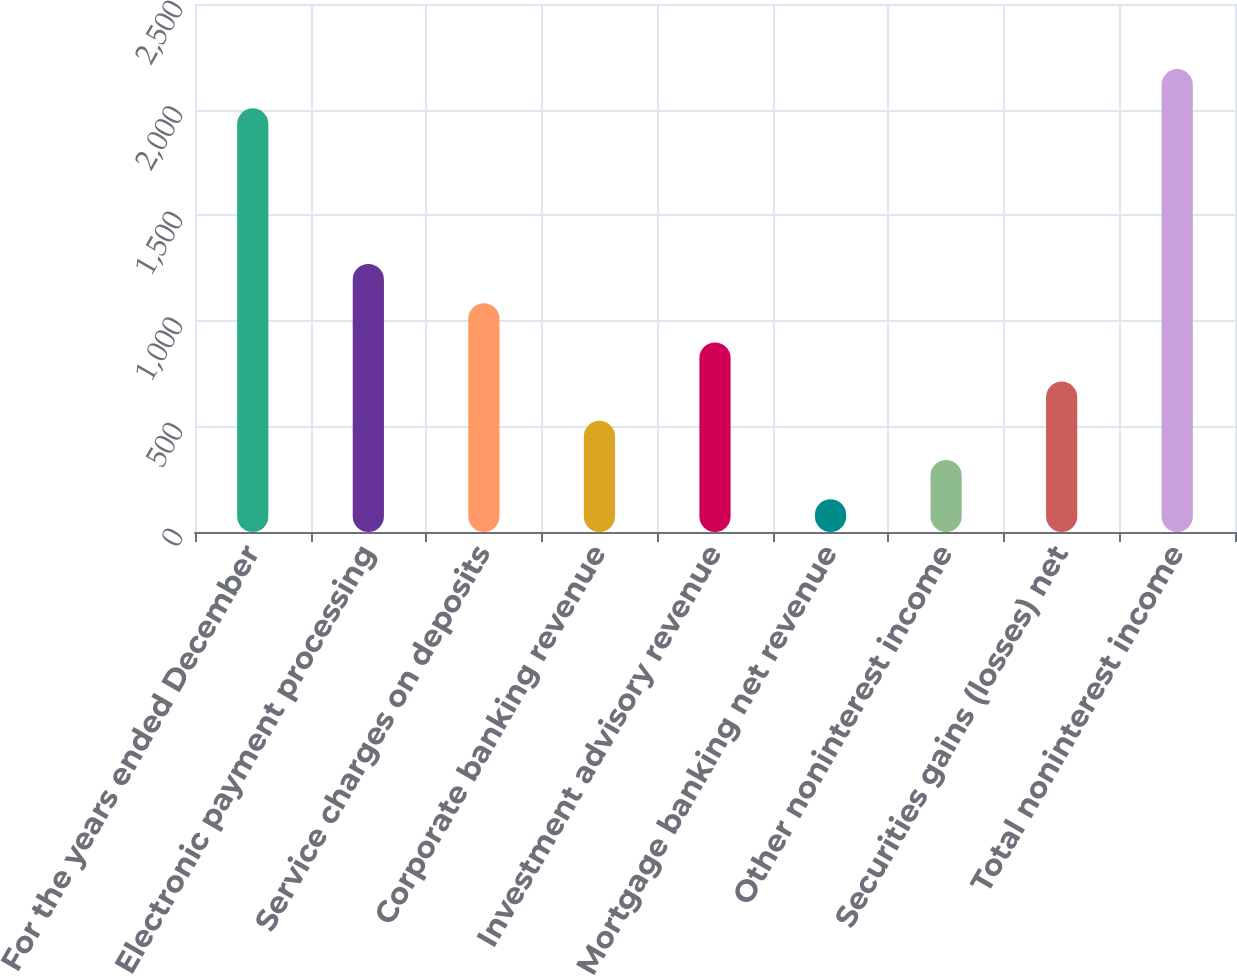Convert chart to OTSL. <chart><loc_0><loc_0><loc_500><loc_500><bar_chart><fcel>For the years ended December<fcel>Electronic payment processing<fcel>Service charges on deposits<fcel>Corporate banking revenue<fcel>Investment advisory revenue<fcel>Mortgage banking net revenue<fcel>Other noninterest income<fcel>Securities gains (losses) net<fcel>Total noninterest income<nl><fcel>2006<fcel>1269.2<fcel>1083.5<fcel>526.4<fcel>897.8<fcel>155<fcel>340.7<fcel>712.1<fcel>2191.7<nl></chart> 